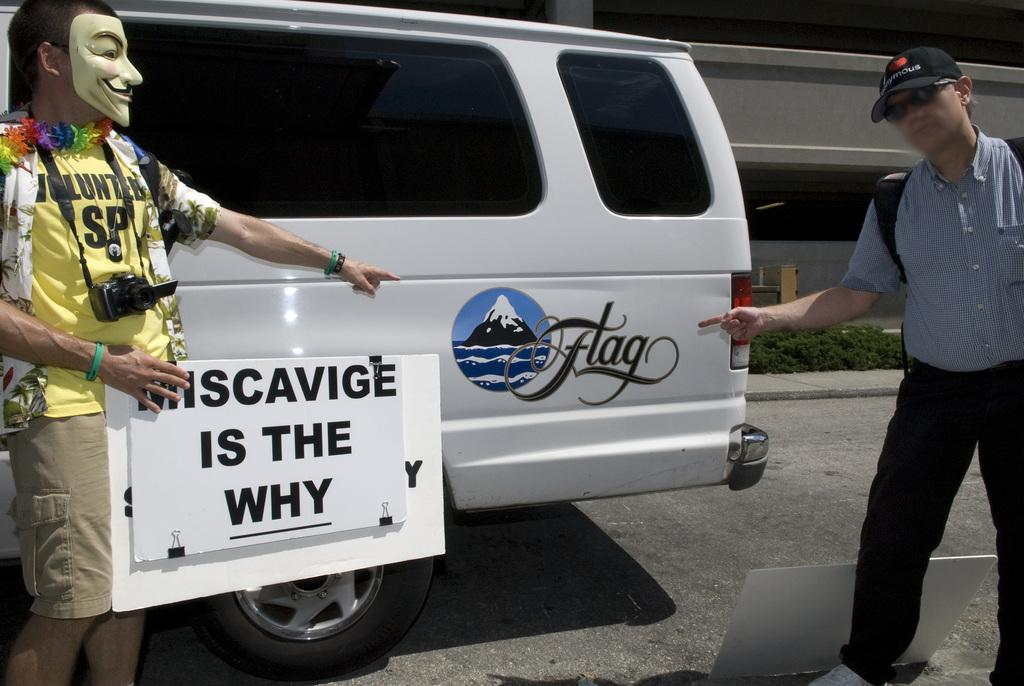<image>
Share a concise interpretation of the image provided. Two men point to a sign on a white van that says "Flag" while one of the men holds a sign that says "Miscavige is the why". 